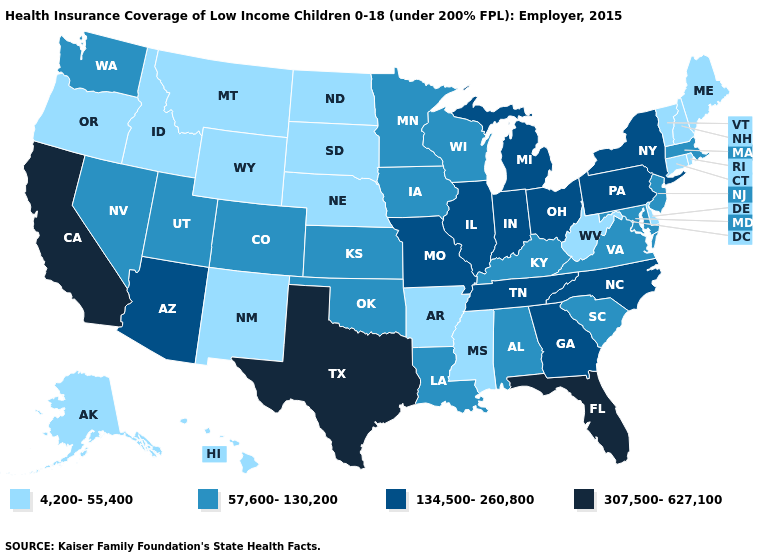Name the states that have a value in the range 57,600-130,200?
Be succinct. Alabama, Colorado, Iowa, Kansas, Kentucky, Louisiana, Maryland, Massachusetts, Minnesota, Nevada, New Jersey, Oklahoma, South Carolina, Utah, Virginia, Washington, Wisconsin. Among the states that border New York , which have the lowest value?
Answer briefly. Connecticut, Vermont. Name the states that have a value in the range 57,600-130,200?
Answer briefly. Alabama, Colorado, Iowa, Kansas, Kentucky, Louisiana, Maryland, Massachusetts, Minnesota, Nevada, New Jersey, Oklahoma, South Carolina, Utah, Virginia, Washington, Wisconsin. What is the value of Maryland?
Answer briefly. 57,600-130,200. Name the states that have a value in the range 134,500-260,800?
Quick response, please. Arizona, Georgia, Illinois, Indiana, Michigan, Missouri, New York, North Carolina, Ohio, Pennsylvania, Tennessee. Name the states that have a value in the range 134,500-260,800?
Concise answer only. Arizona, Georgia, Illinois, Indiana, Michigan, Missouri, New York, North Carolina, Ohio, Pennsylvania, Tennessee. What is the lowest value in the Northeast?
Keep it brief. 4,200-55,400. What is the value of Michigan?
Be succinct. 134,500-260,800. Name the states that have a value in the range 307,500-627,100?
Quick response, please. California, Florida, Texas. Among the states that border Virginia , which have the highest value?
Keep it brief. North Carolina, Tennessee. Among the states that border Massachusetts , which have the highest value?
Answer briefly. New York. Which states have the lowest value in the USA?
Give a very brief answer. Alaska, Arkansas, Connecticut, Delaware, Hawaii, Idaho, Maine, Mississippi, Montana, Nebraska, New Hampshire, New Mexico, North Dakota, Oregon, Rhode Island, South Dakota, Vermont, West Virginia, Wyoming. What is the value of Oregon?
Write a very short answer. 4,200-55,400. Which states hav the highest value in the South?
Answer briefly. Florida, Texas. Name the states that have a value in the range 307,500-627,100?
Concise answer only. California, Florida, Texas. 